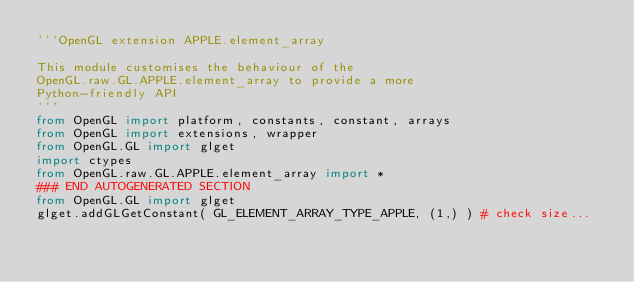Convert code to text. <code><loc_0><loc_0><loc_500><loc_500><_Python_>'''OpenGL extension APPLE.element_array

This module customises the behaviour of the 
OpenGL.raw.GL.APPLE.element_array to provide a more 
Python-friendly API
'''
from OpenGL import platform, constants, constant, arrays
from OpenGL import extensions, wrapper
from OpenGL.GL import glget
import ctypes
from OpenGL.raw.GL.APPLE.element_array import *
### END AUTOGENERATED SECTION
from OpenGL.GL import glget
glget.addGLGetConstant( GL_ELEMENT_ARRAY_TYPE_APPLE, (1,) ) # check size...
</code> 